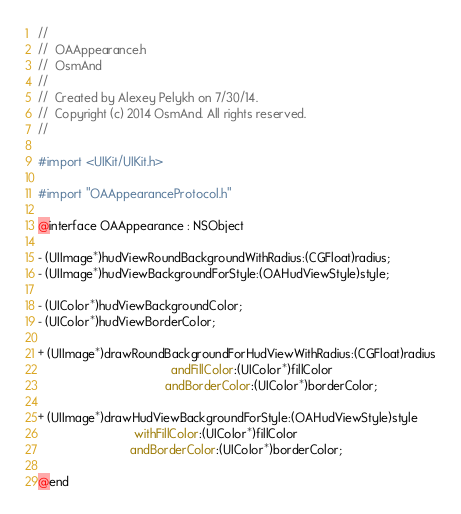Convert code to text. <code><loc_0><loc_0><loc_500><loc_500><_C_>//
//  OAAppearance.h
//  OsmAnd
//
//  Created by Alexey Pelykh on 7/30/14.
//  Copyright (c) 2014 OsmAnd. All rights reserved.
//

#import <UIKit/UIKit.h>

#import "OAAppearanceProtocol.h"

@interface OAAppearance : NSObject

- (UIImage*)hudViewRoundBackgroundWithRadius:(CGFloat)radius;
- (UIImage*)hudViewBackgroundForStyle:(OAHudViewStyle)style;

- (UIColor*)hudViewBackgroundColor;
- (UIColor*)hudViewBorderColor;

+ (UIImage*)drawRoundBackgroundForHudViewWithRadius:(CGFloat)radius
                                       andFillColor:(UIColor*)fillColor
                                     andBorderColor:(UIColor*)borderColor;

+ (UIImage*)drawHudViewBackgroundForStyle:(OAHudViewStyle)style
                            withFillColor:(UIColor*)fillColor
                           andBorderColor:(UIColor*)borderColor;

@end
</code> 